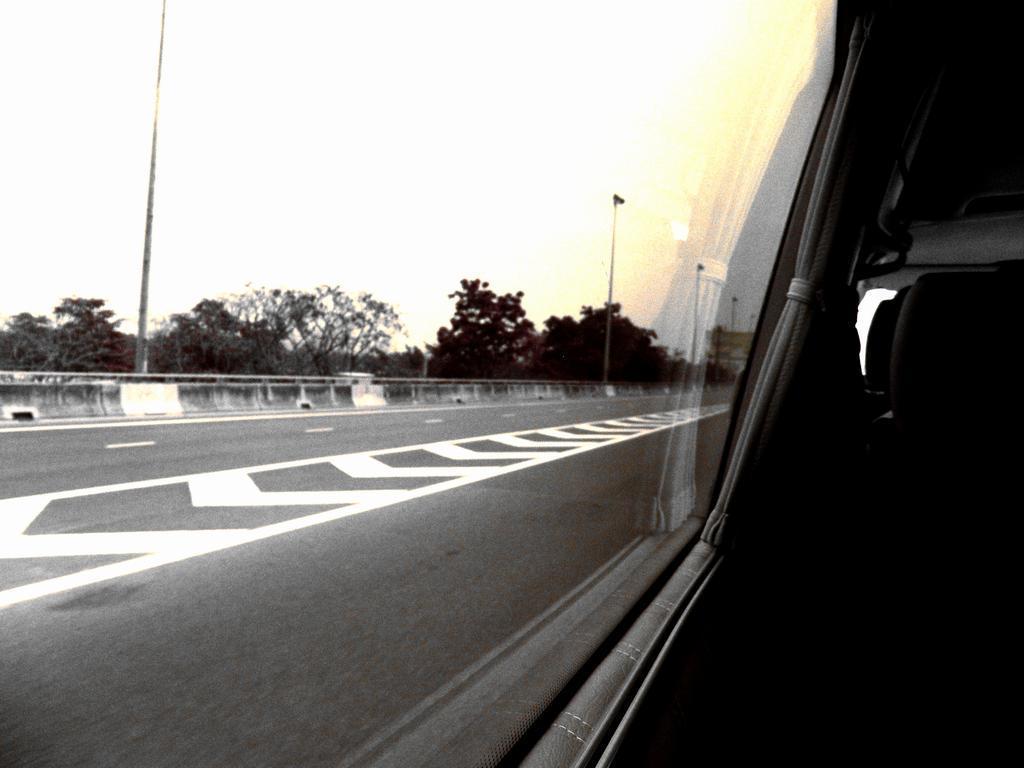How would you summarize this image in a sentence or two? On the right side there are seats in a car, on left side there is a road, in the background there are poles, railing, trees and the sky. 